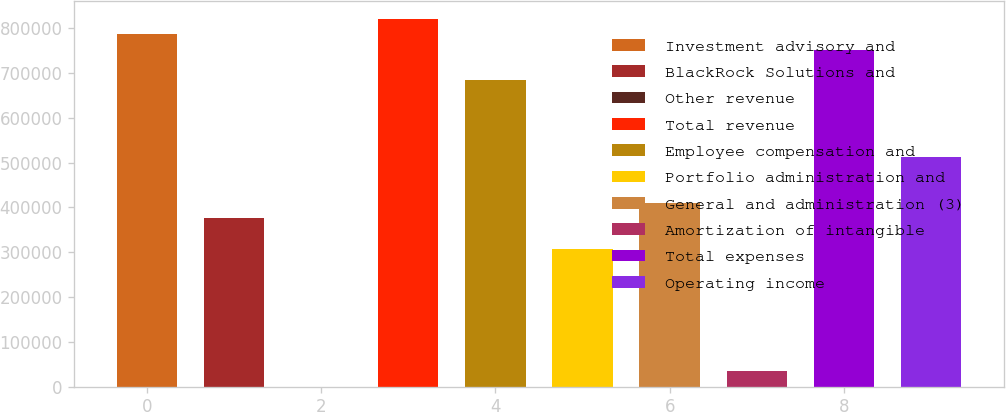<chart> <loc_0><loc_0><loc_500><loc_500><bar_chart><fcel>Investment advisory and<fcel>BlackRock Solutions and<fcel>Other revenue<fcel>Total revenue<fcel>Employee compensation and<fcel>Portfolio administration and<fcel>General and administration (3)<fcel>Amortization of intangible<fcel>Total expenses<fcel>Operating income<nl><fcel>786047<fcel>375936<fcel>1<fcel>820223<fcel>683519<fcel>307584<fcel>410112<fcel>34176.9<fcel>751871<fcel>512640<nl></chart> 